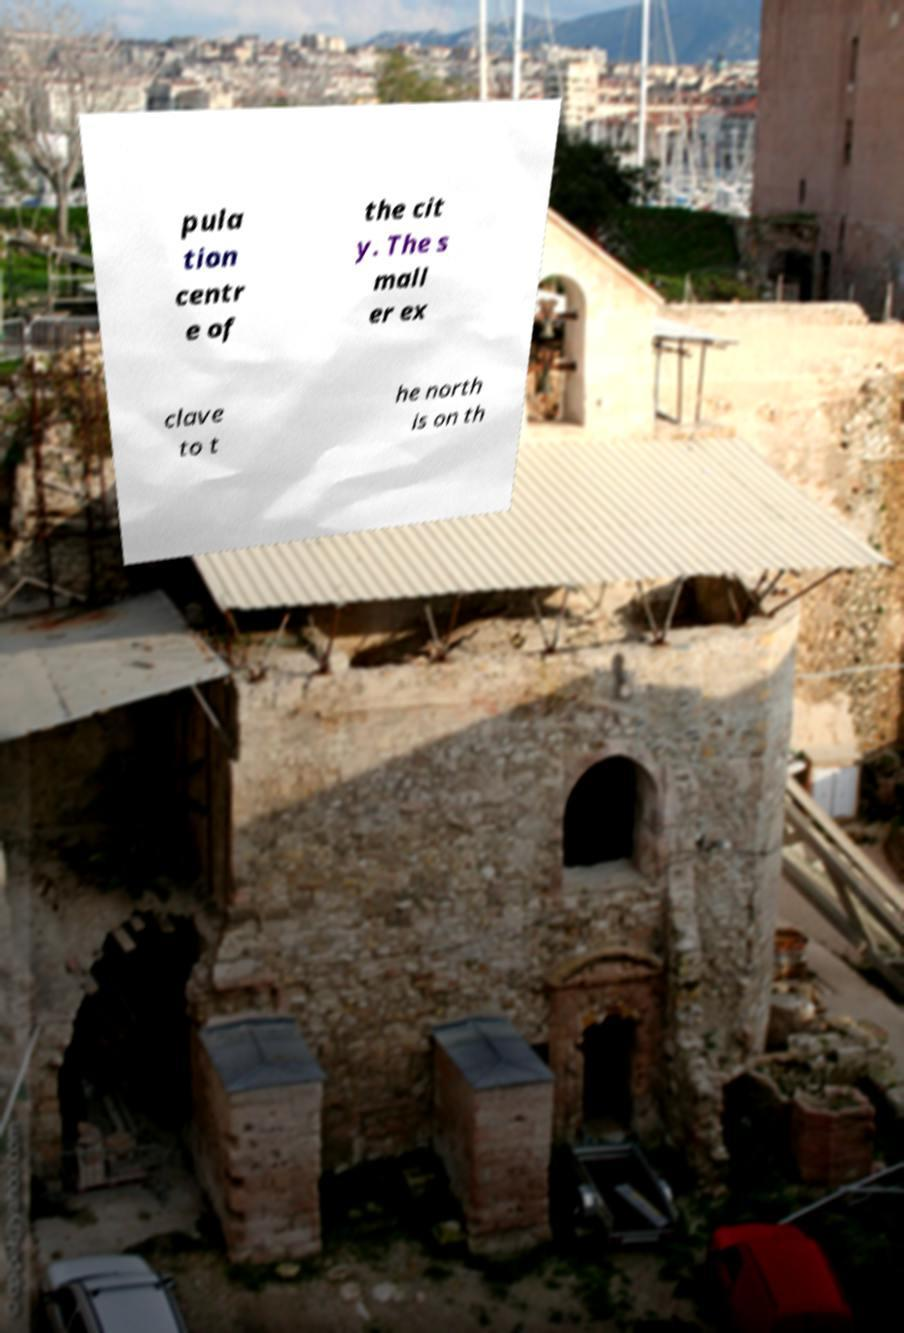What messages or text are displayed in this image? I need them in a readable, typed format. pula tion centr e of the cit y. The s mall er ex clave to t he north is on th 